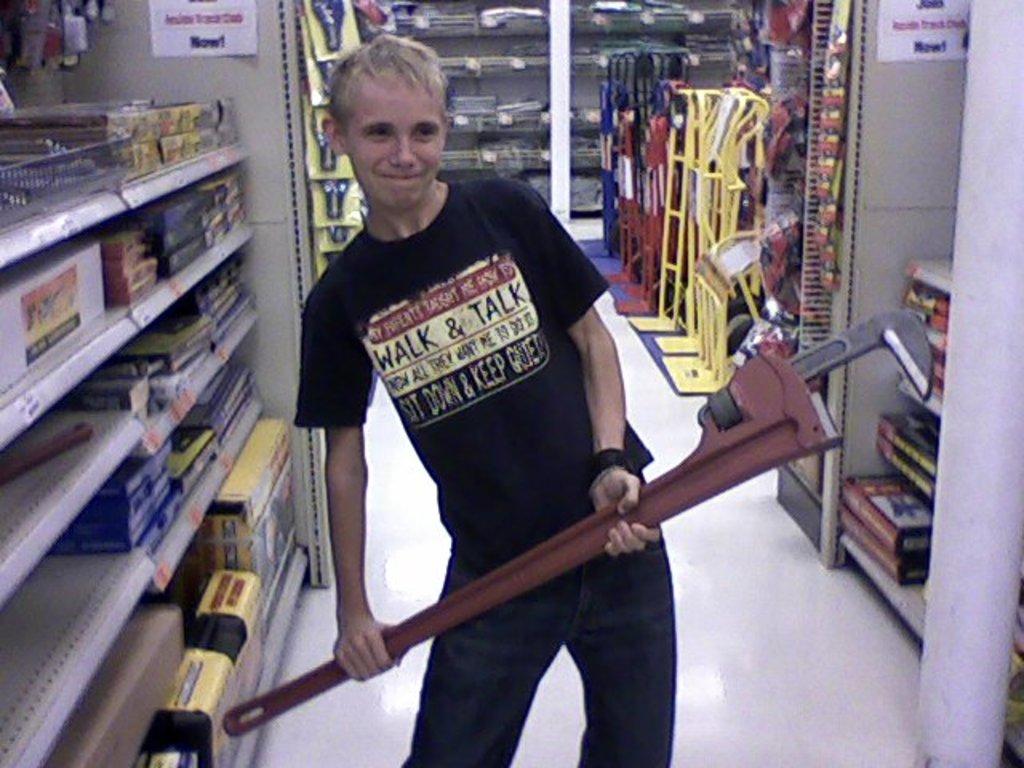If he sits down, what else doe he have to do?
Offer a very short reply. Keep quiet. Is walk or talk mentioned on his shirt?
Keep it short and to the point. Yes. 